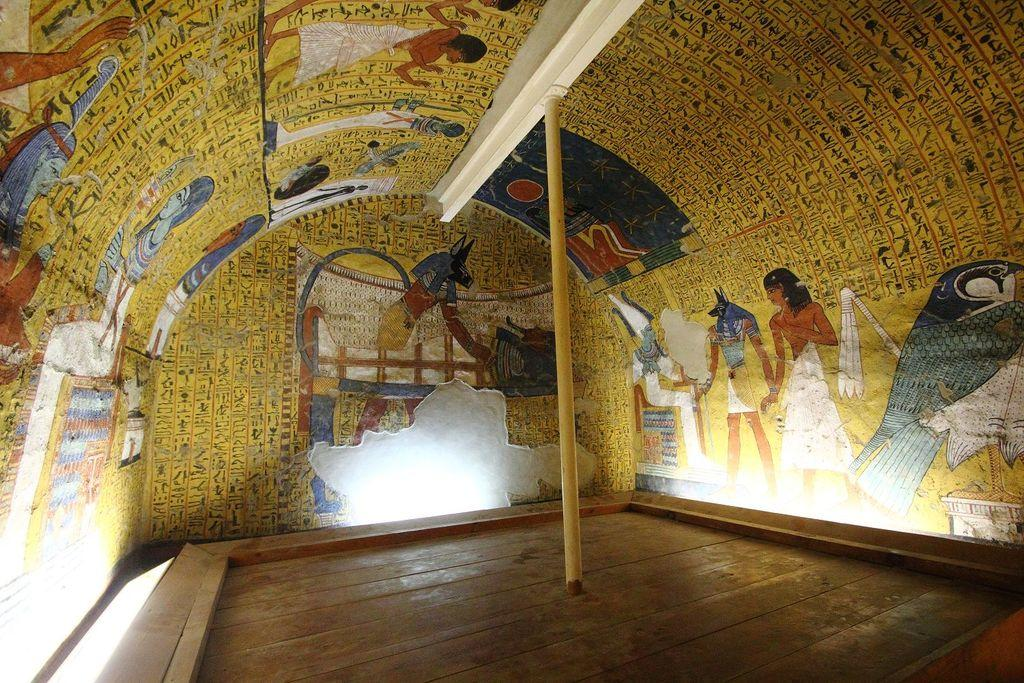What is the main object in the center of the image? There is a pole in the center of the image. What can be seen on the wall in the image? There are posters on the wall in the image. What type of curtain is hanging from the pole in the image? There is no curtain present in the image; only the pole and posters on the wall are visible. What kind of animal can be seen interacting with the posters in the image? There are no animals present in the image; it only features a pole and posters on the wall. 